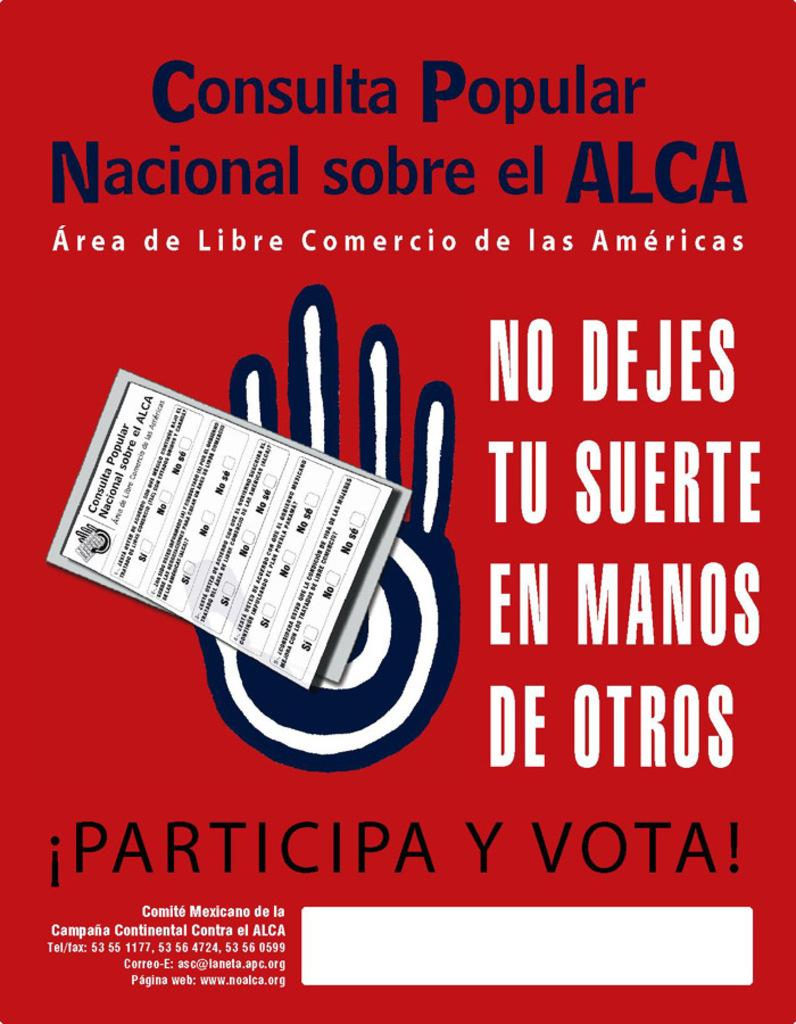<image>
Describe the image concisely. !Participa Y Vota! tells people to vote in Spanish. 